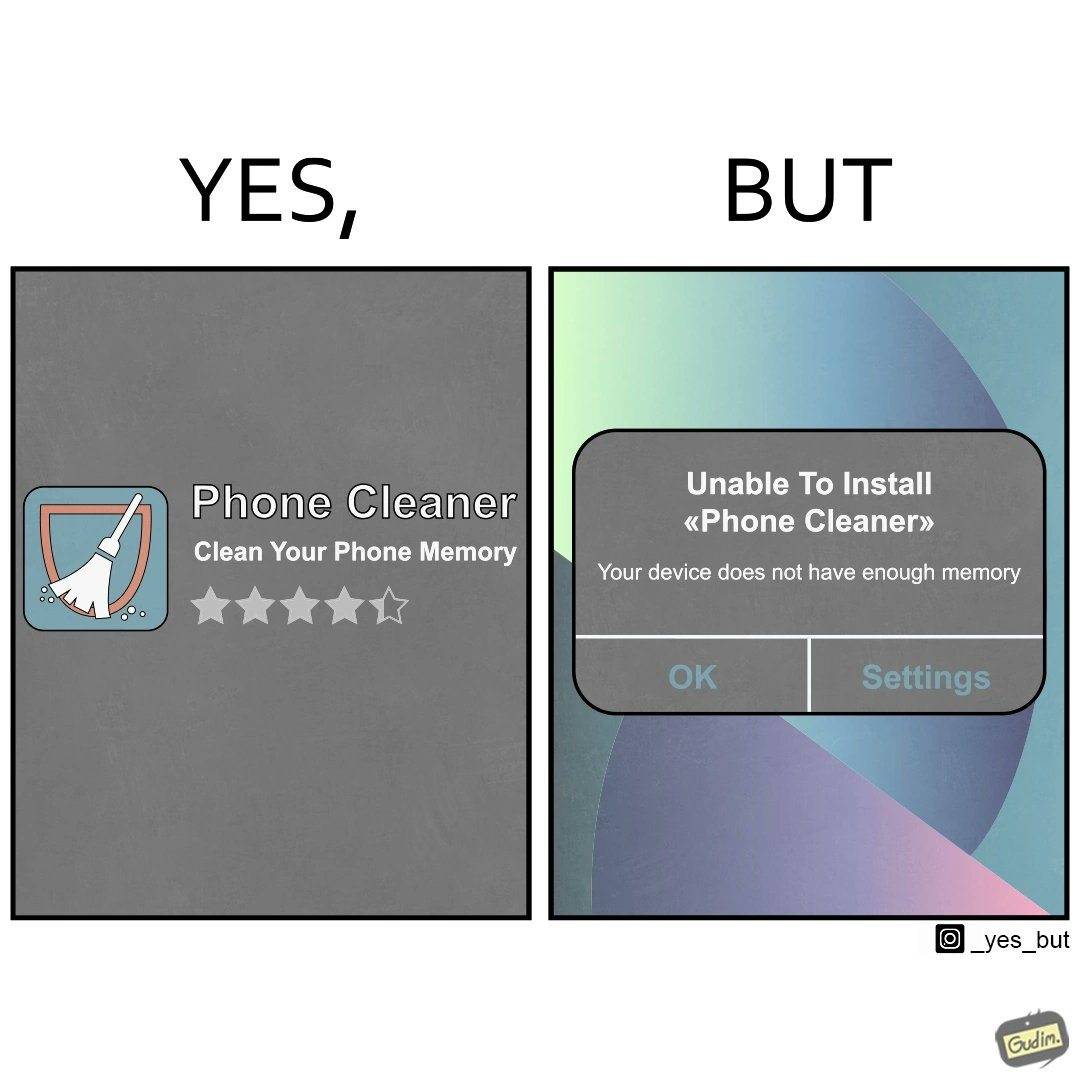Provide a description of this image. The image is ironical, as to clear the phone's memory using phone cleaner app, one has to install it, but that is not possible in turn due to the phone memory being full. 